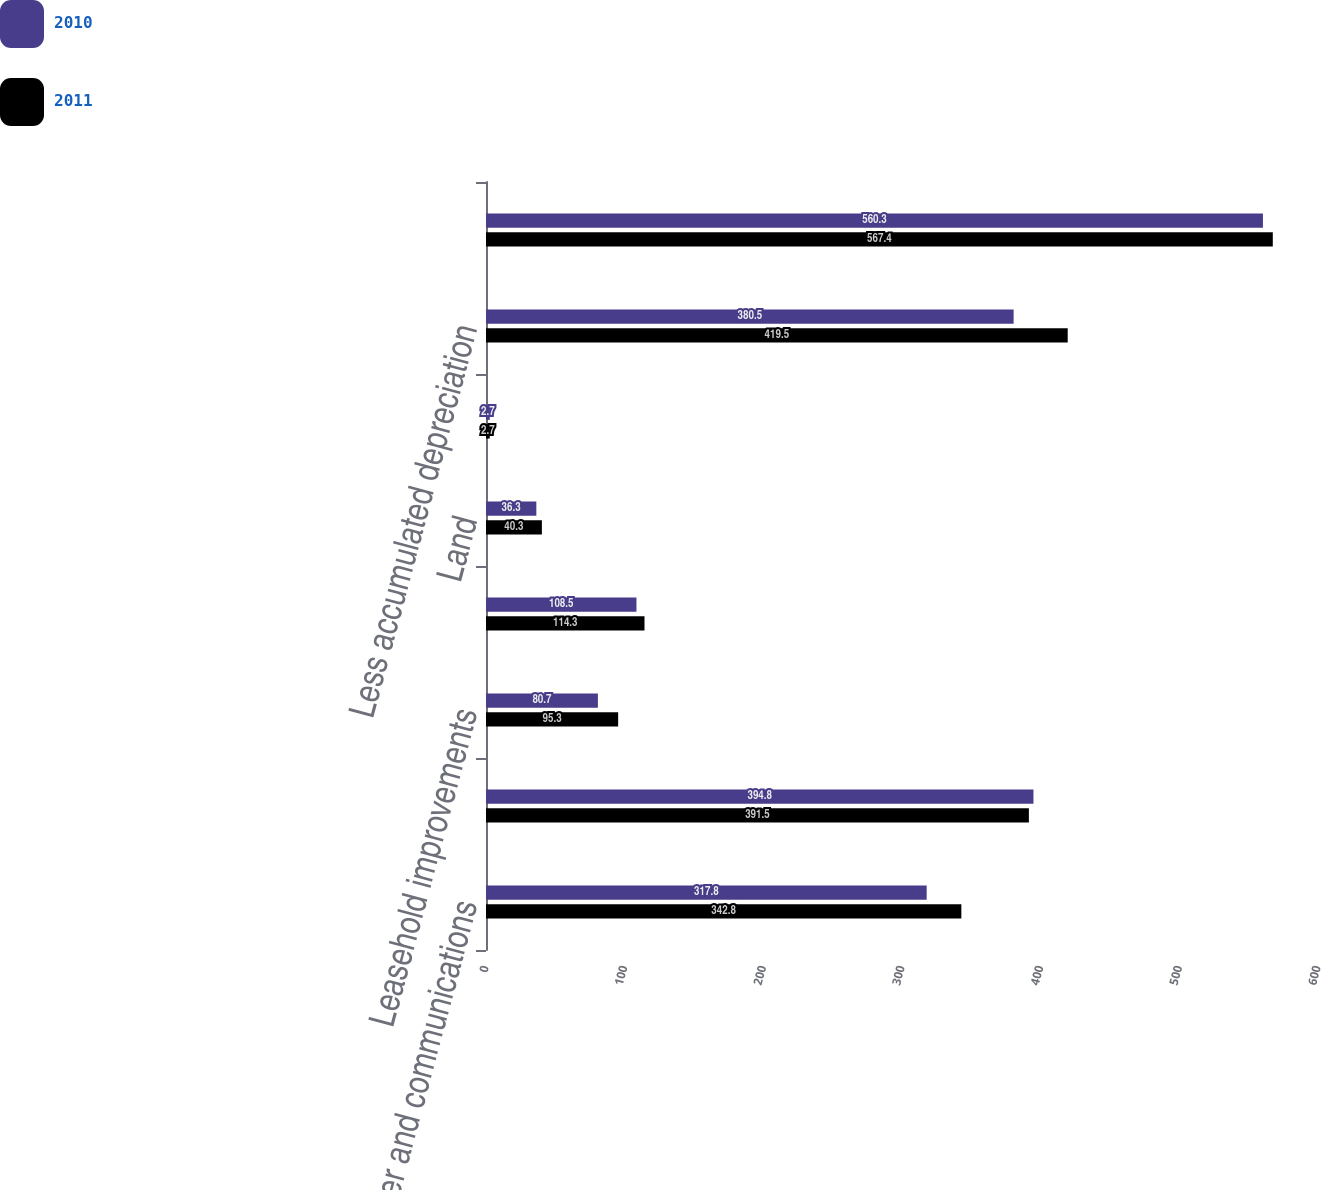Convert chart to OTSL. <chart><loc_0><loc_0><loc_500><loc_500><stacked_bar_chart><ecel><fcel>Computer and communications<fcel>Buildings and improvements<fcel>Leasehold improvements<fcel>Furniture and other equipment<fcel>Land<fcel>Leased land<fcel>Less accumulated depreciation<fcel>Total<nl><fcel>2010<fcel>317.8<fcel>394.8<fcel>80.7<fcel>108.5<fcel>36.3<fcel>2.7<fcel>380.5<fcel>560.3<nl><fcel>2011<fcel>342.8<fcel>391.5<fcel>95.3<fcel>114.3<fcel>40.3<fcel>2.7<fcel>419.5<fcel>567.4<nl></chart> 